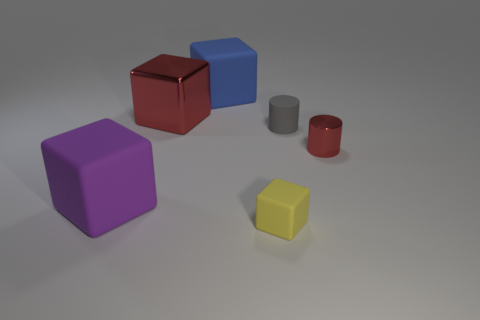Add 2 cylinders. How many objects exist? 8 Subtract all cubes. How many objects are left? 2 Subtract all big purple objects. Subtract all gray objects. How many objects are left? 4 Add 5 small yellow rubber cubes. How many small yellow rubber cubes are left? 6 Add 4 big matte objects. How many big matte objects exist? 6 Subtract 0 brown spheres. How many objects are left? 6 